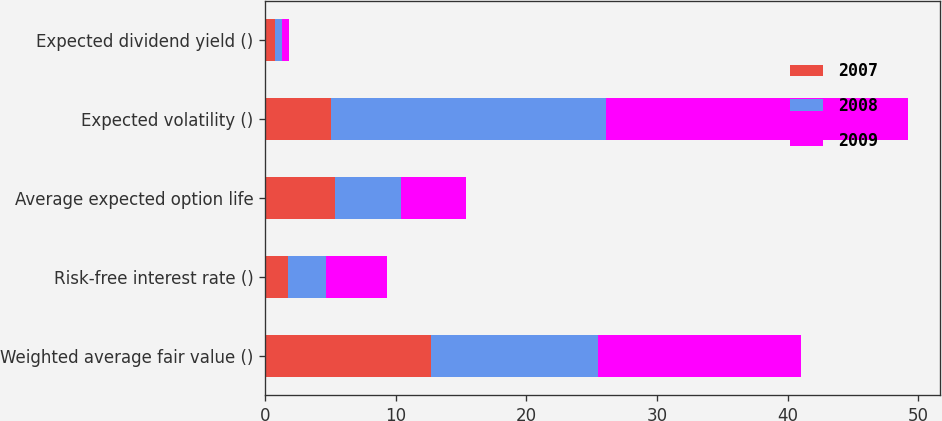Convert chart to OTSL. <chart><loc_0><loc_0><loc_500><loc_500><stacked_bar_chart><ecel><fcel>Weighted average fair value ()<fcel>Risk-free interest rate ()<fcel>Average expected option life<fcel>Expected volatility ()<fcel>Expected dividend yield ()<nl><fcel>2007<fcel>12.68<fcel>1.78<fcel>5.37<fcel>5.02<fcel>0.78<nl><fcel>2008<fcel>12.83<fcel>2.87<fcel>5.02<fcel>21.1<fcel>0.53<nl><fcel>2009<fcel>15.5<fcel>4.69<fcel>5.02<fcel>23.08<fcel>0.5<nl></chart> 